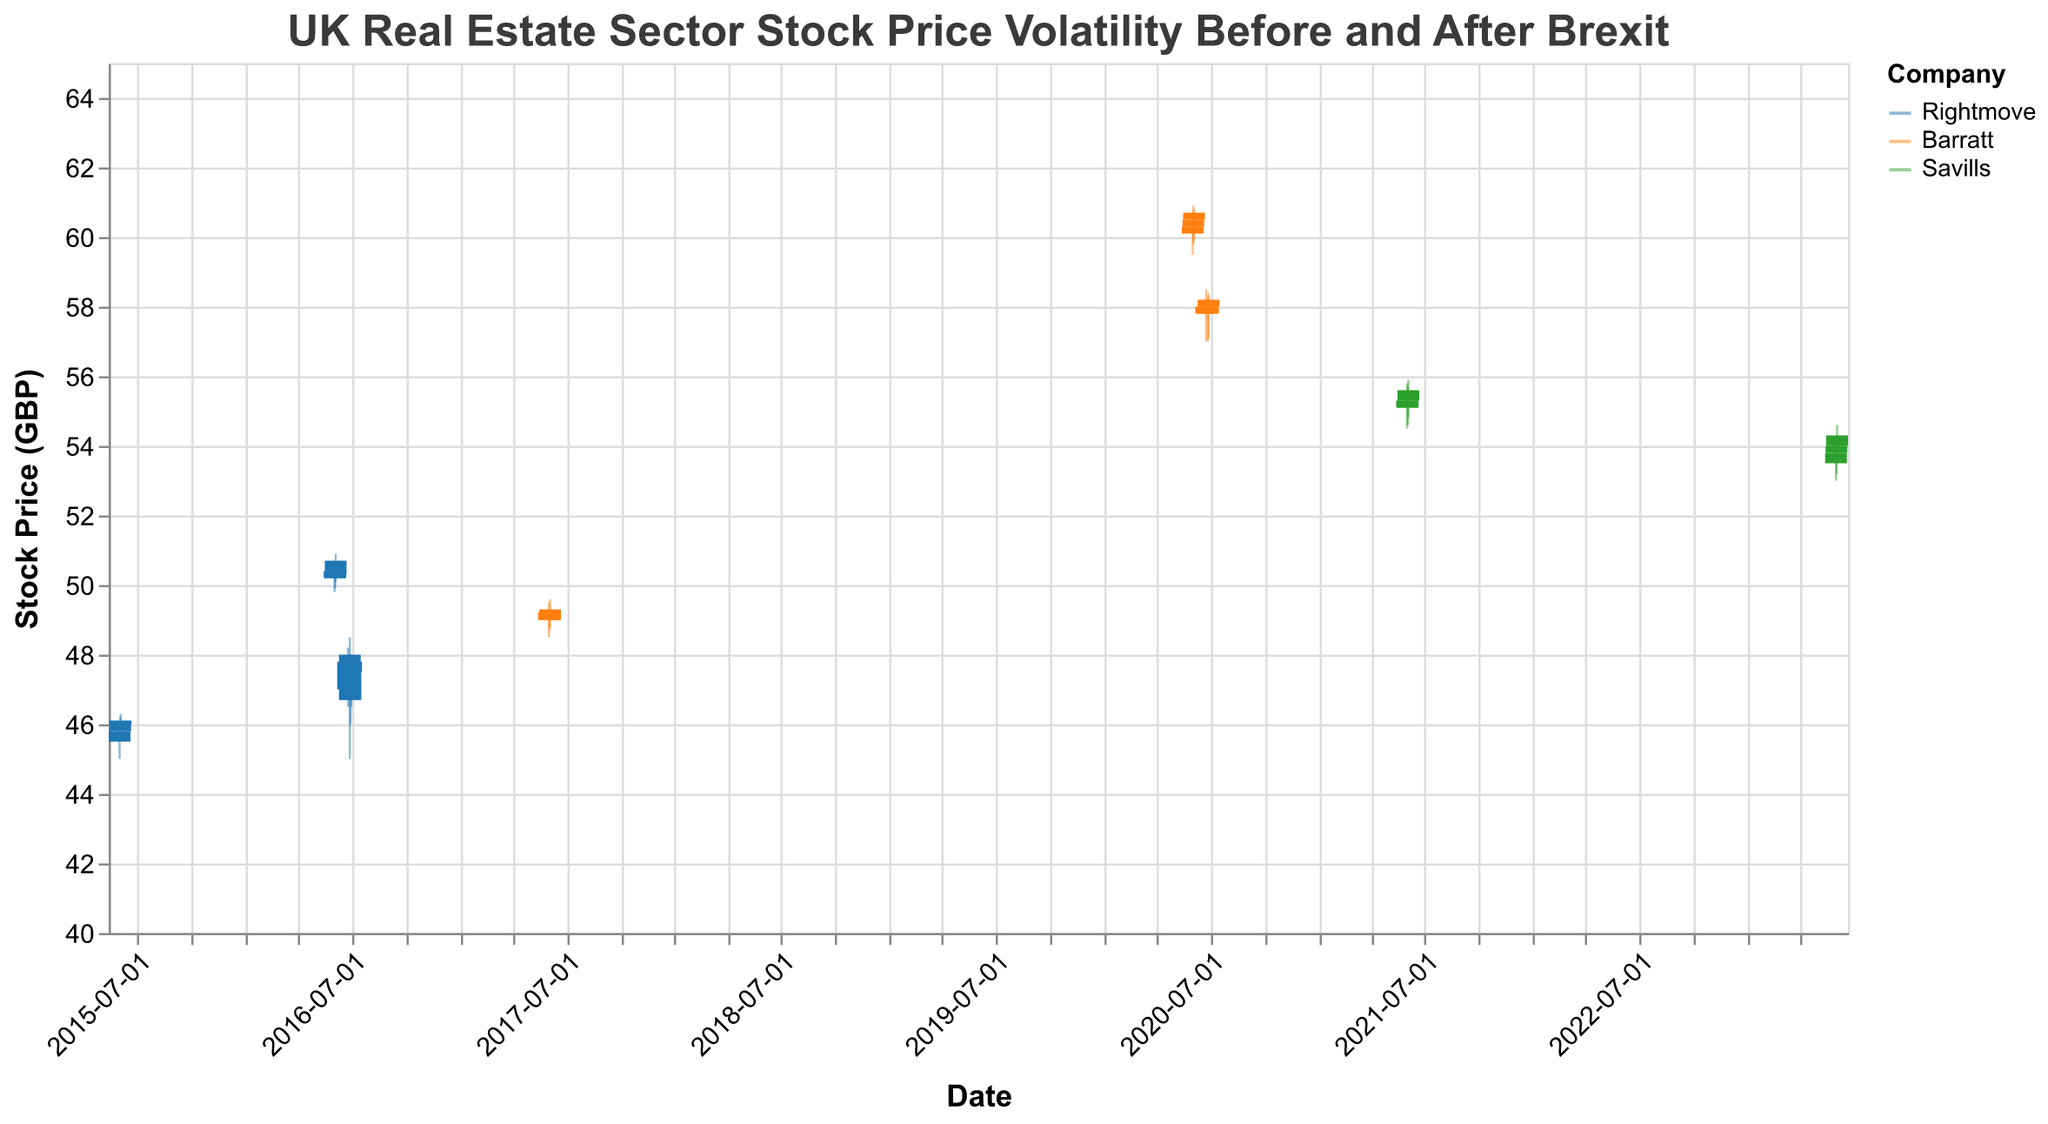How does the title of the plot describe its content? The title "UK Real Estate Sector Stock Price Volatility Before and After Brexit" suggests that the plot visualizes the changes in stock prices in the UK's real estate sector specifically before and after the Brexit event.
Answer: It describes the UK real estate sector stock price volatility around Brexit What is the range of the y-axis representing stock prices? The y-axis is labeled "Stock Price (GBP)" and ranges from 40 to 65 GBP.
Answer: 40 to 65 GBP Which company has the highest closing stock price in 2020? By looking at the color-coded bar in 2020 for Barratt, and its closing prices on June 1, 2, and 3, we see the highest close price was on June 3, at 60.70 GBP.
Answer: Barratt Comparing the stocks of Rightmove and Barratt, which company experienced higher trading volume on June 24, 2016? Rightmove’s trading volume on June 24, 2016 was 500,000, which is higher than Barratt's trading volume on June 24, 2020 with 540,000.
Answer: Barratt How did the stock price of Rightmove change from June 24, 2016, to June 29, 2016? On June 24, 2016, Rightmove's stock closed at 47.80 GBP. Subsequently, on June 27, it dropped to 46.70 GBP, then on June 28, it increased to 47.50 GBP, and finally on June 29, it closed at 47.80 GBP again.
Answer: It dropped, then increased back to 47.80 GBP What is the total trading volume for Savills in the year 2021? Summing up the volume traded on June 1, 2, and 3 for Savills in 2021, the values are 250,000 + 245,000 + 260,000 = 755,000.
Answer: 755,000 Which company displayed the widest range between high and low prices on any single trading day post-Brexit? By analyzing the differences between high and low prices post-Brexit for each company, Barratt on June 24, 2020, has the widest range of 58.50 - 57.00 = 1.50 GBP.
Answer: Barratt Was there a significant drop in Rightmove's stock price immediately after Brexit? On June 24, 2016, Rightmove's stock closed at 47.80 GBP and significantly dropped on June 27 to 46.70 GBP, indicating a considerable drop in the immediate aftermath of Brexit.
Answer: Yes Which company had a higher average closing price in 2023? Comparing closing prices of Savills in 2023: average(53.80, 54.00, 54.30) is (53.80 + 54.00 + 54.30) / 3 = 54.03 GBP, no other companies presented for comparison.
Answer: Savills 